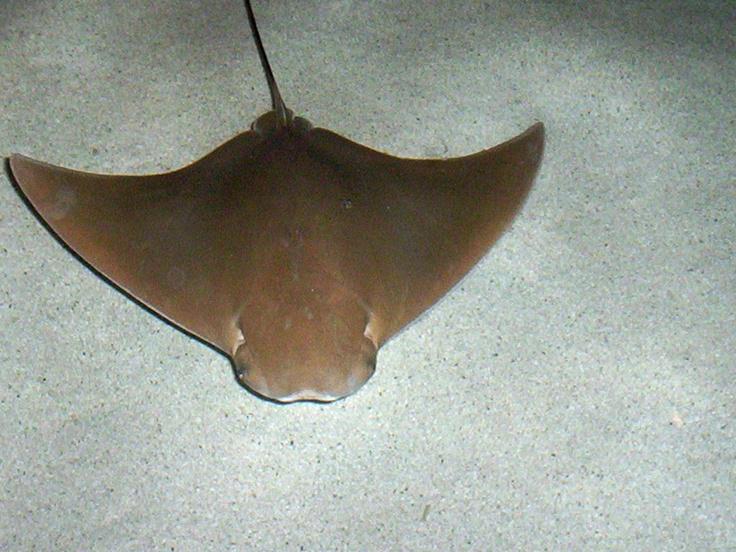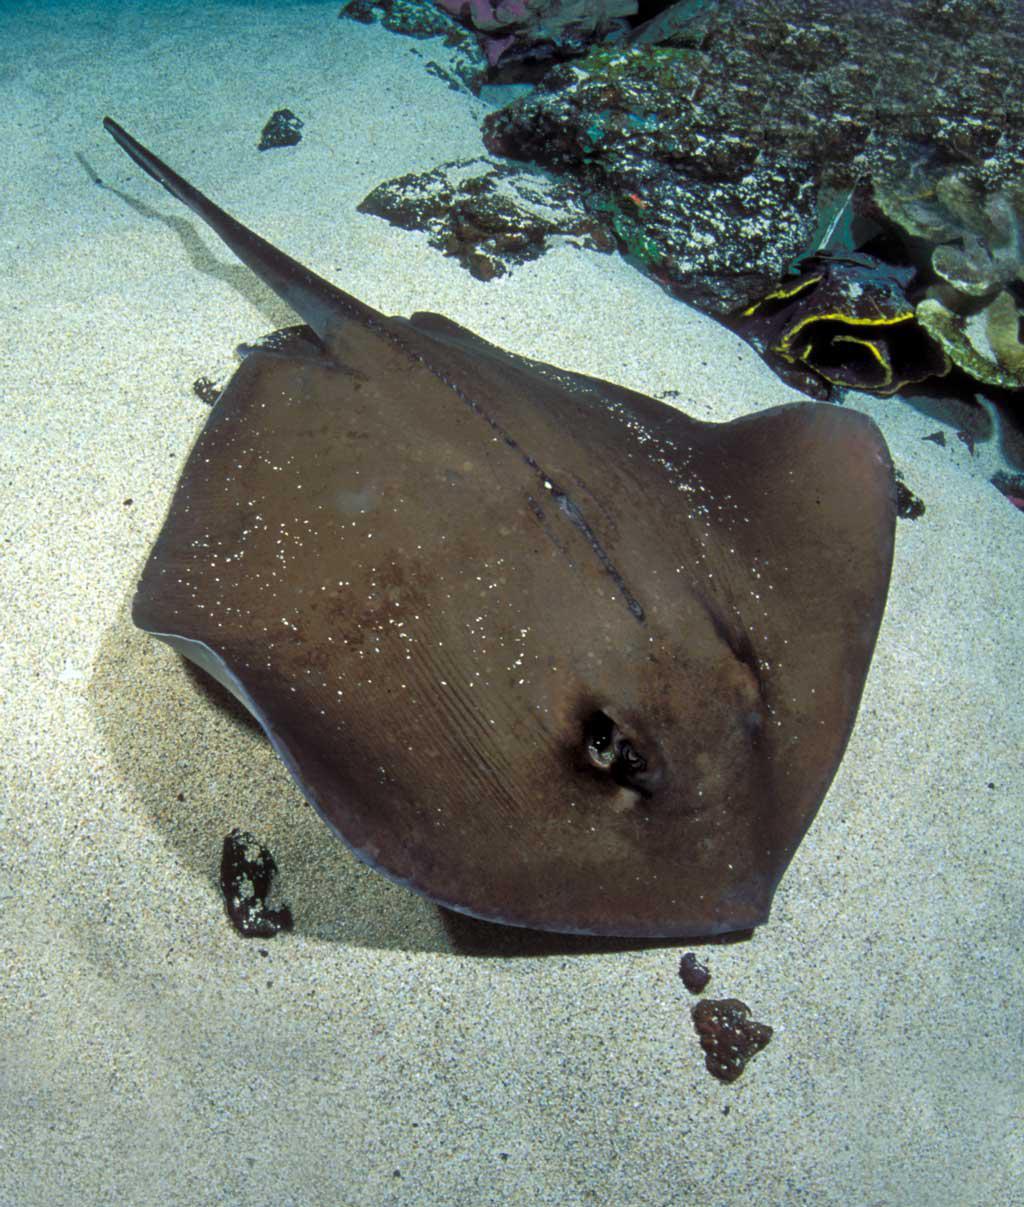The first image is the image on the left, the second image is the image on the right. For the images shown, is this caption "Both stingrays have white spots and their tails are pointed in different directions." true? Answer yes or no. No. 